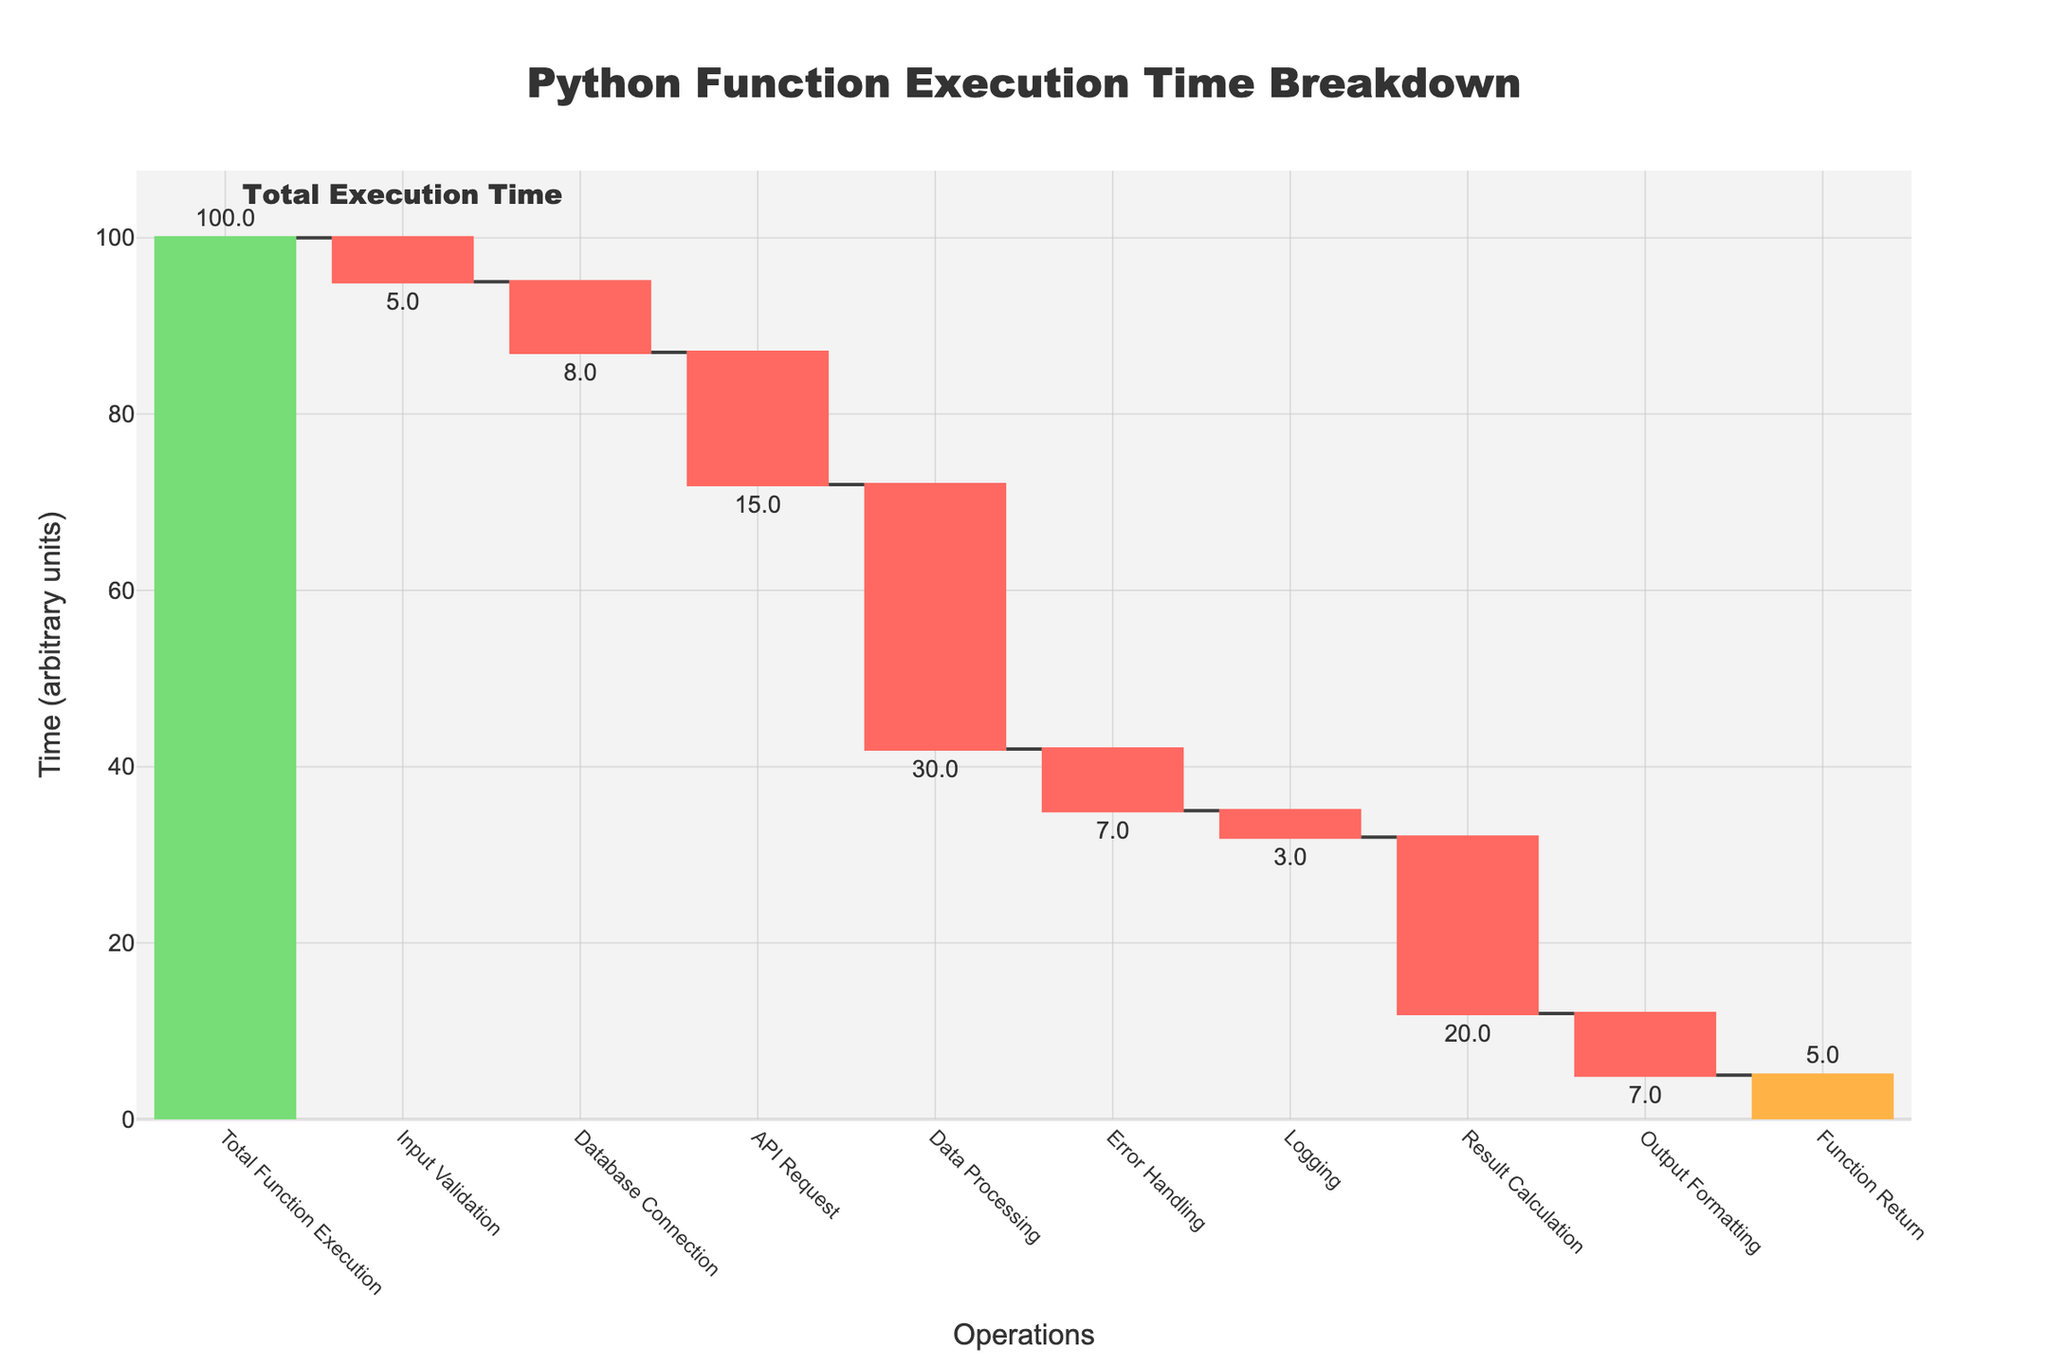What's the total execution time for the function? The total execution time is given by the "Total Function Execution" operation at the end of the chart. It is 100.
Answer: 100 Which operation has the largest negative impact on the execution time? The operation with the largest negative impact is the one with the highest negative value. "Data Processing" decreases the time by 30, which is the largest negative impact in the chart.
Answer: Data Processing By how much does Input Validation decrease the execution time? The "Input Validation" operation has a negative value indicating a decrease. The chart shows it decreases the time by 5.
Answer: 5 What is the combined effect of Database Connection and API Request? To find the combined effect, sum the impact of the "Database Connection" (-8) and "API Request" (-15). The combined value is -23.
Answer: -23 How does Result Calculation compare to Error Handling in terms of impact on execution time? "Result Calculation" decreases the time by 20, while "Error Handling" decreases the time by 7. Result Calculation has a larger negative impact.
Answer: Result Calculation has a larger impact What's the overall effect of all operations except Function Return? Sum the effects of all operations excluding "Function Return" to find the overall impact: -5 + (-8) + (-15) + (-30) + (-7) + (-3) + (-20) + (-7) = -95. Then consider the starting point, the combined effect is 100 (total) - 5 = 95.
Answer: 95 What color represents decreasing operations? The chart uses a red color to represent decreasing operations as specified in the parameters.
Answer: Red Which operations have positive impact on execution time? The operations with positive values are marked in green. Only "Function Return" has a positive value of 5.
Answer: Function Return 